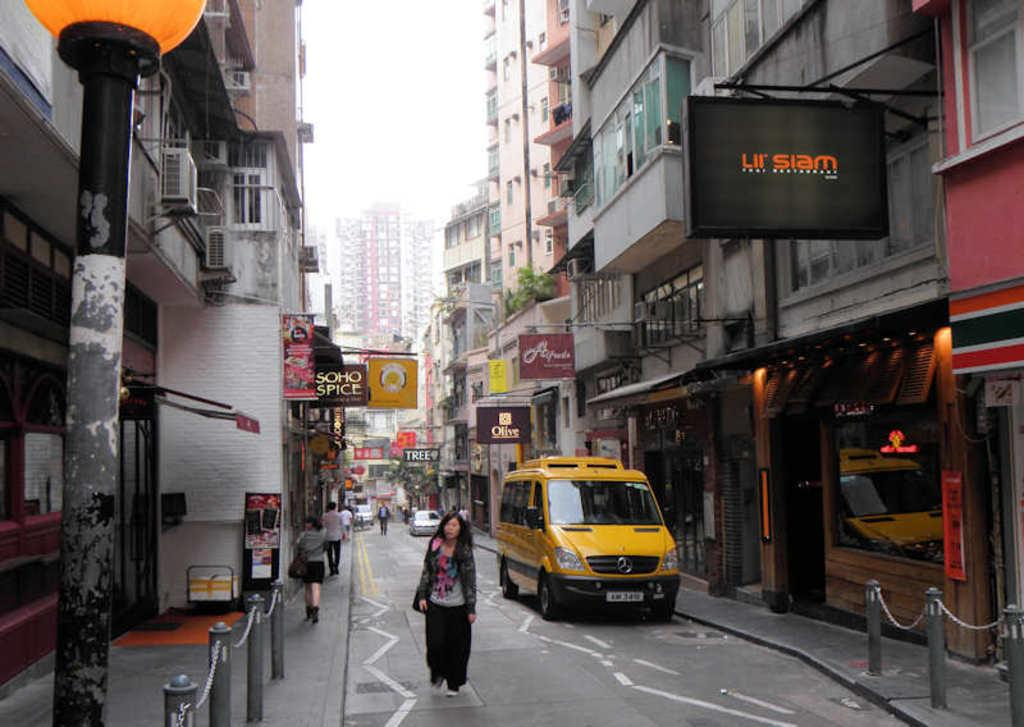<image>
Write a terse but informative summary of the picture. A yellow van on right side on street near a black LII Siam sign. 